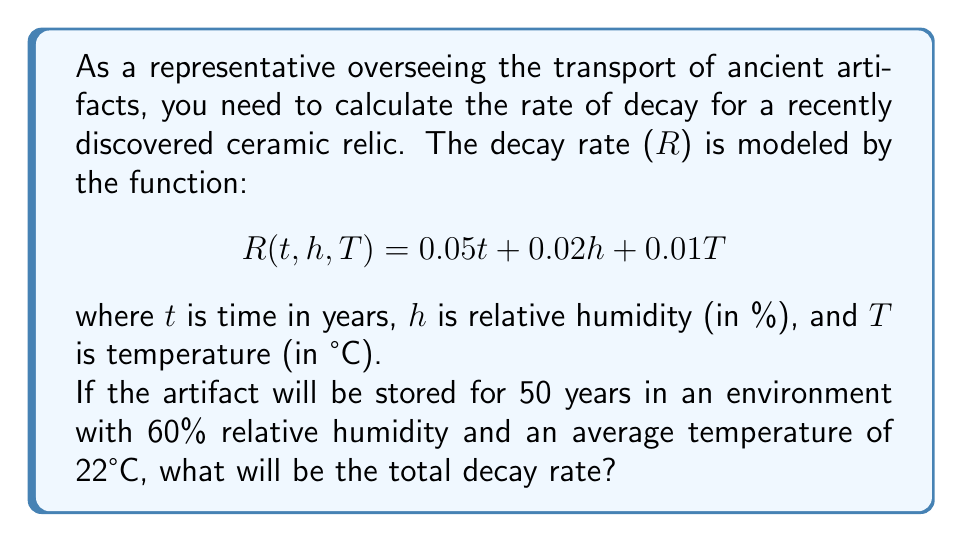Can you answer this question? To solve this problem, we need to substitute the given values into the decay rate function:

1. Time (t) = 50 years
2. Relative humidity (h) = 60%
3. Temperature (T) = 22°C

Let's substitute these values into the function:

$$R(50, 60, 22) = 0.05(50) + 0.02(60) + 0.01(22)$$

Now, let's calculate each term:

1. $0.05(50) = 2.5$
2. $0.02(60) = 1.2$
3. $0.01(22) = 0.22$

Adding these terms together:

$$R = 2.5 + 1.2 + 0.22 = 3.92$$

Therefore, the total decay rate for the artifact under these conditions over 50 years will be 3.92.
Answer: $R = 3.92$ 